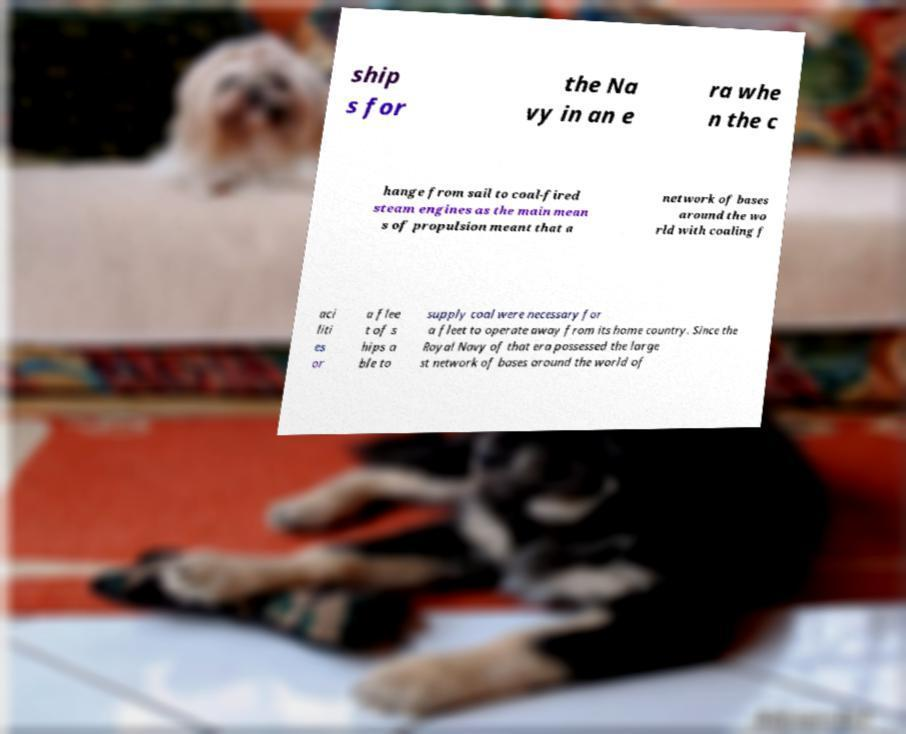Please identify and transcribe the text found in this image. ship s for the Na vy in an e ra whe n the c hange from sail to coal-fired steam engines as the main mean s of propulsion meant that a network of bases around the wo rld with coaling f aci liti es or a flee t of s hips a ble to supply coal were necessary for a fleet to operate away from its home country. Since the Royal Navy of that era possessed the large st network of bases around the world of 